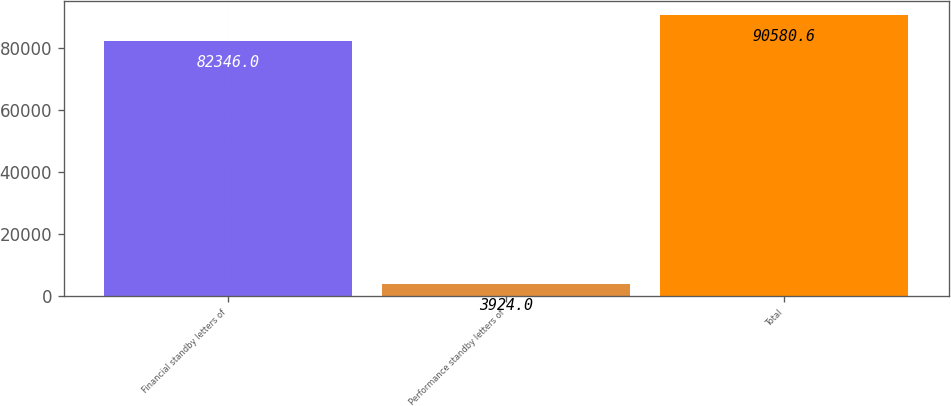<chart> <loc_0><loc_0><loc_500><loc_500><bar_chart><fcel>Financial standby letters of<fcel>Performance standby letters of<fcel>Total<nl><fcel>82346<fcel>3924<fcel>90580.6<nl></chart> 